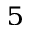Convert formula to latex. <formula><loc_0><loc_0><loc_500><loc_500>^ { 5 }</formula> 